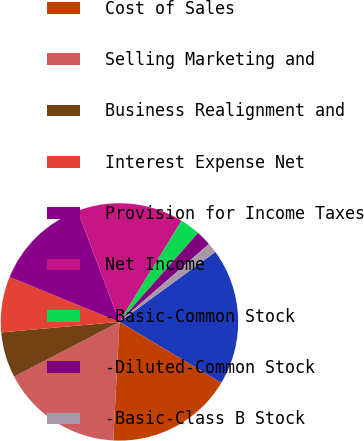Convert chart to OTSL. <chart><loc_0><loc_0><loc_500><loc_500><pie_chart><fcel>Net Sales<fcel>Cost of Sales<fcel>Selling Marketing and<fcel>Business Realignment and<fcel>Interest Expense Net<fcel>Provision for Income Taxes<fcel>Net Income<fcel>-Basic-Common Stock<fcel>-Diluted-Common Stock<fcel>-Basic-Class B Stock<nl><fcel>18.62%<fcel>17.24%<fcel>16.55%<fcel>6.21%<fcel>7.59%<fcel>13.1%<fcel>14.48%<fcel>2.76%<fcel>2.07%<fcel>1.38%<nl></chart> 